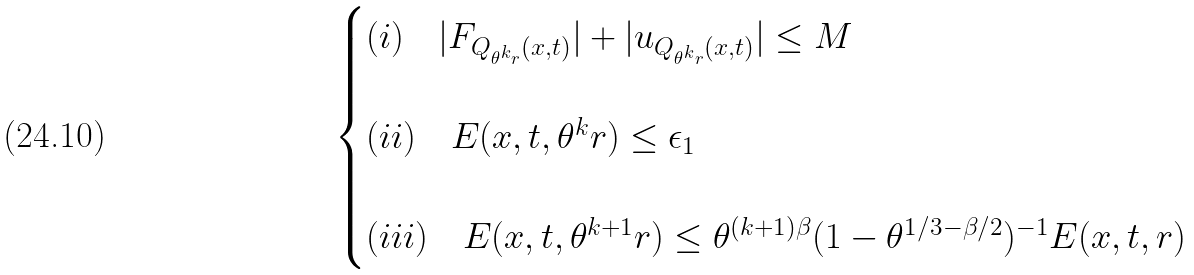Convert formula to latex. <formula><loc_0><loc_0><loc_500><loc_500>\begin{cases} ( i ) \quad | F _ { Q _ { \theta ^ { k } r } ( x , t ) } | + | u _ { Q _ { \theta ^ { k } r } ( x , t ) } | \leq M \\ \\ ( i i ) \quad E ( x , t , \theta ^ { k } r ) \leq \epsilon _ { 1 } \\ \\ ( i i i ) \quad E ( x , t , \theta ^ { k + 1 } r ) \leq \theta ^ { ( k + 1 ) \beta } ( 1 - \theta ^ { 1 / 3 - \beta / 2 } ) ^ { - 1 } E ( x , t , r ) \end{cases}</formula> 